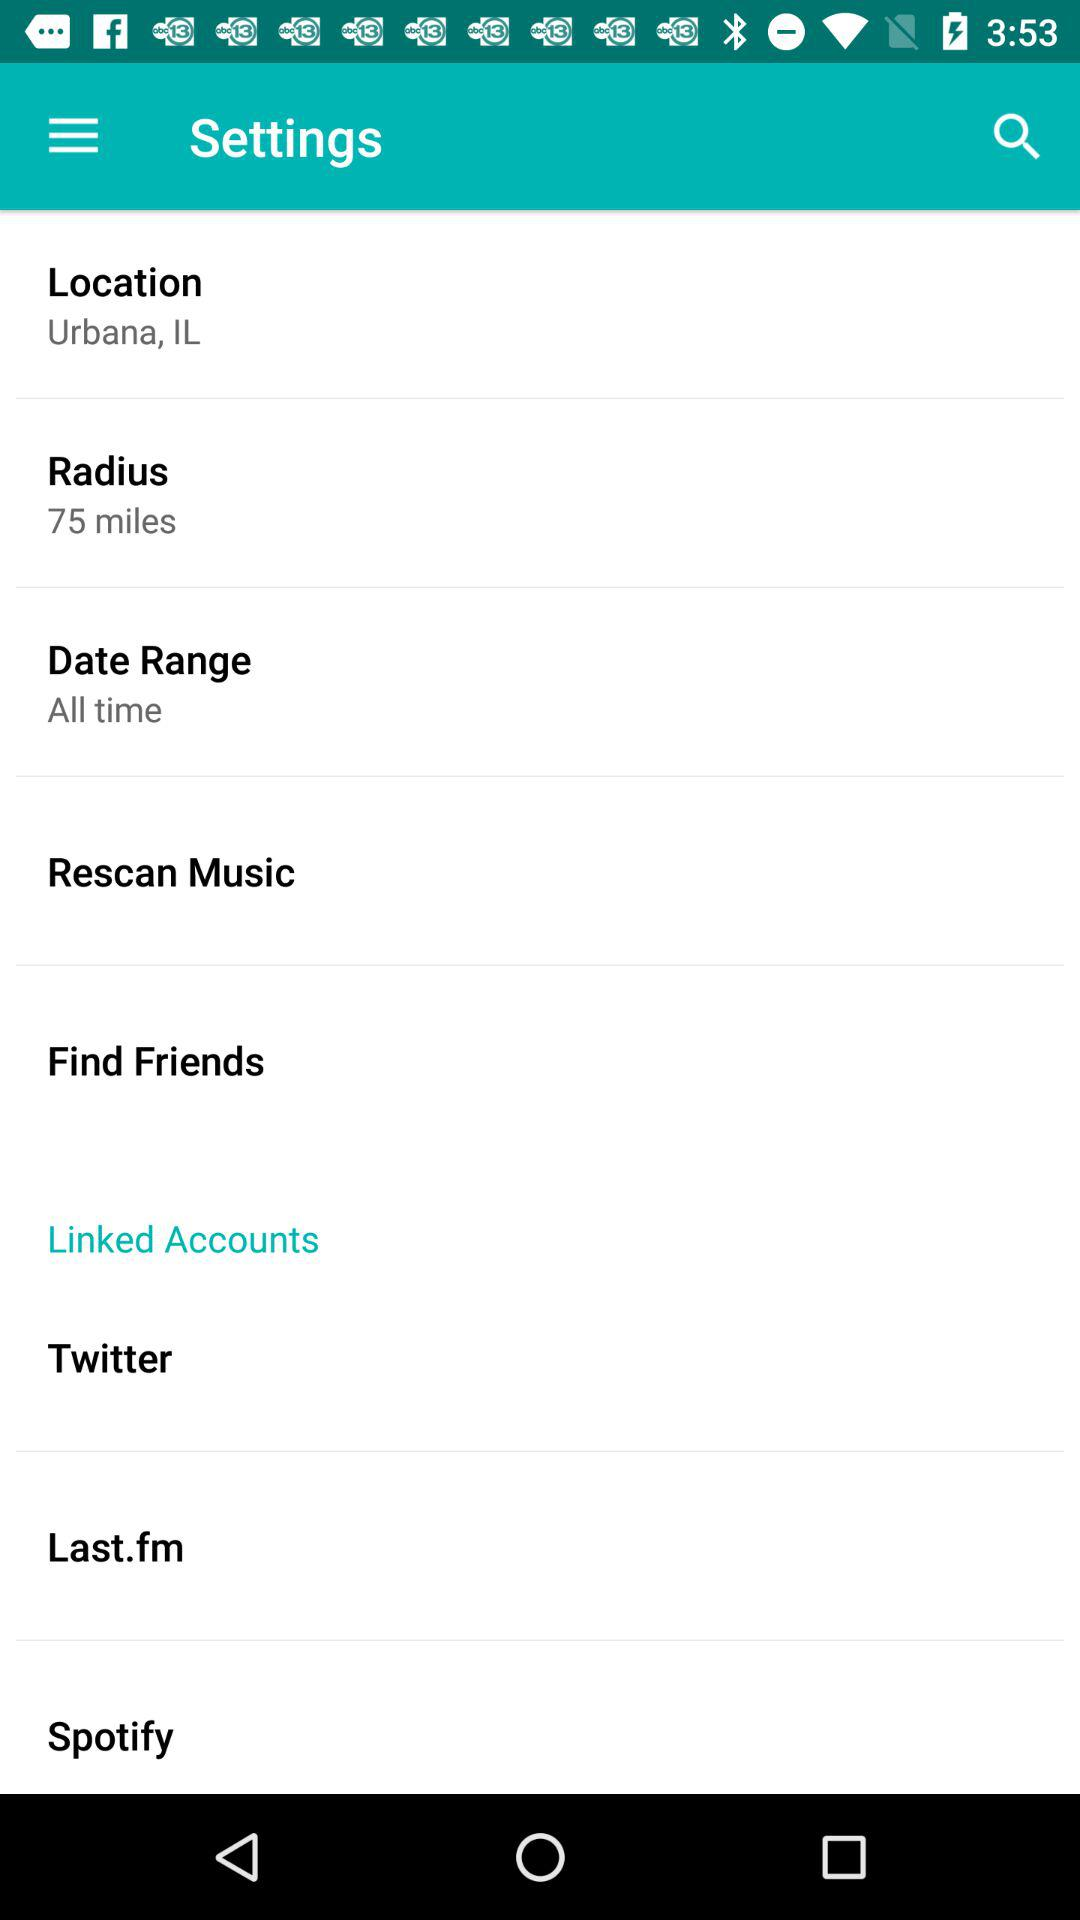What location is selected? The selected location is Urbana, IL. 